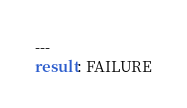<code> <loc_0><loc_0><loc_500><loc_500><_YAML_>---
result: FAILURE</code> 